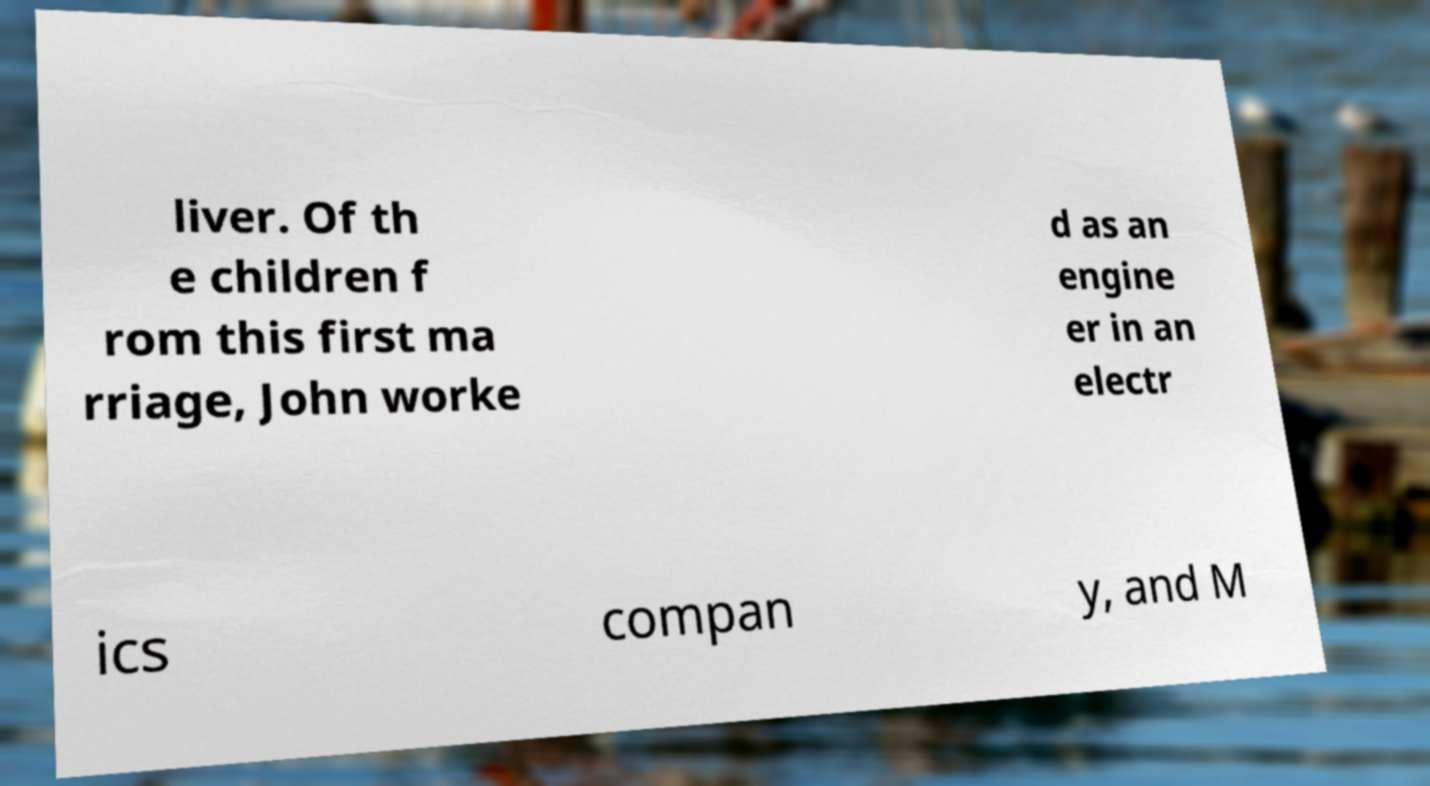What messages or text are displayed in this image? I need them in a readable, typed format. liver. Of th e children f rom this first ma rriage, John worke d as an engine er in an electr ics compan y, and M 